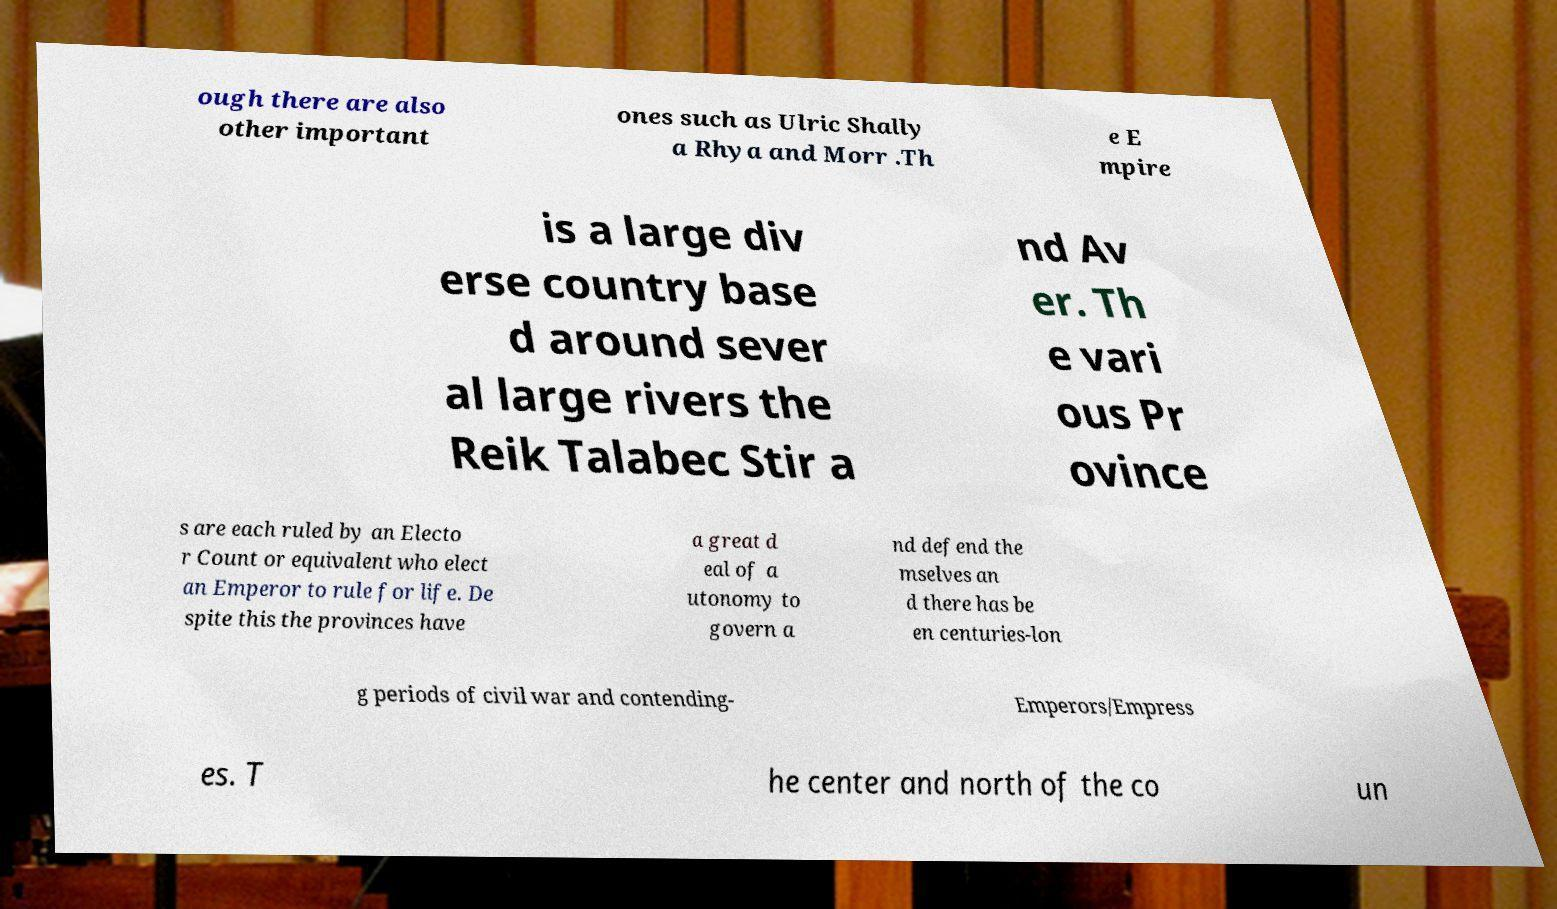Please identify and transcribe the text found in this image. ough there are also other important ones such as Ulric Shally a Rhya and Morr .Th e E mpire is a large div erse country base d around sever al large rivers the Reik Talabec Stir a nd Av er. Th e vari ous Pr ovince s are each ruled by an Electo r Count or equivalent who elect an Emperor to rule for life. De spite this the provinces have a great d eal of a utonomy to govern a nd defend the mselves an d there has be en centuries-lon g periods of civil war and contending- Emperors/Empress es. T he center and north of the co un 